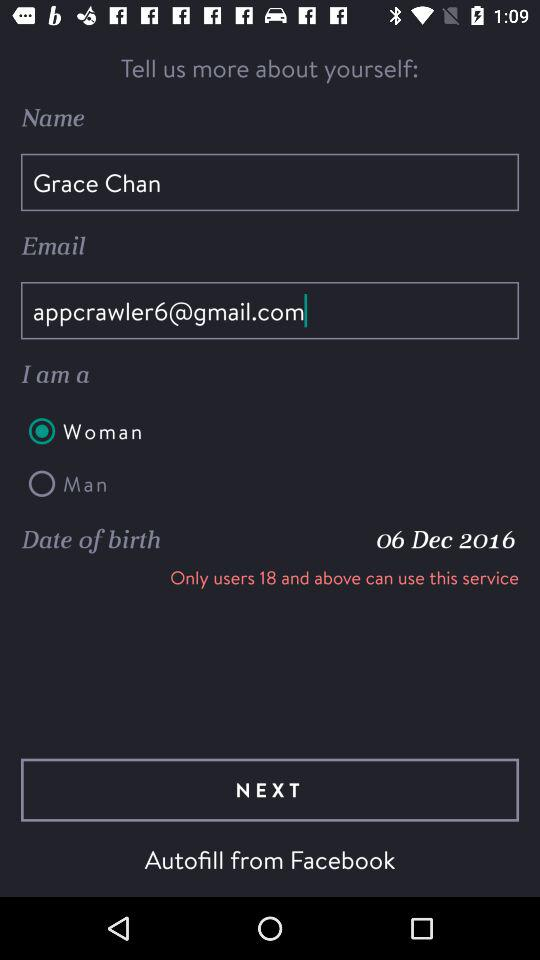What is the date of birth of the user? The date of birth of the user is December 6, 2016. 